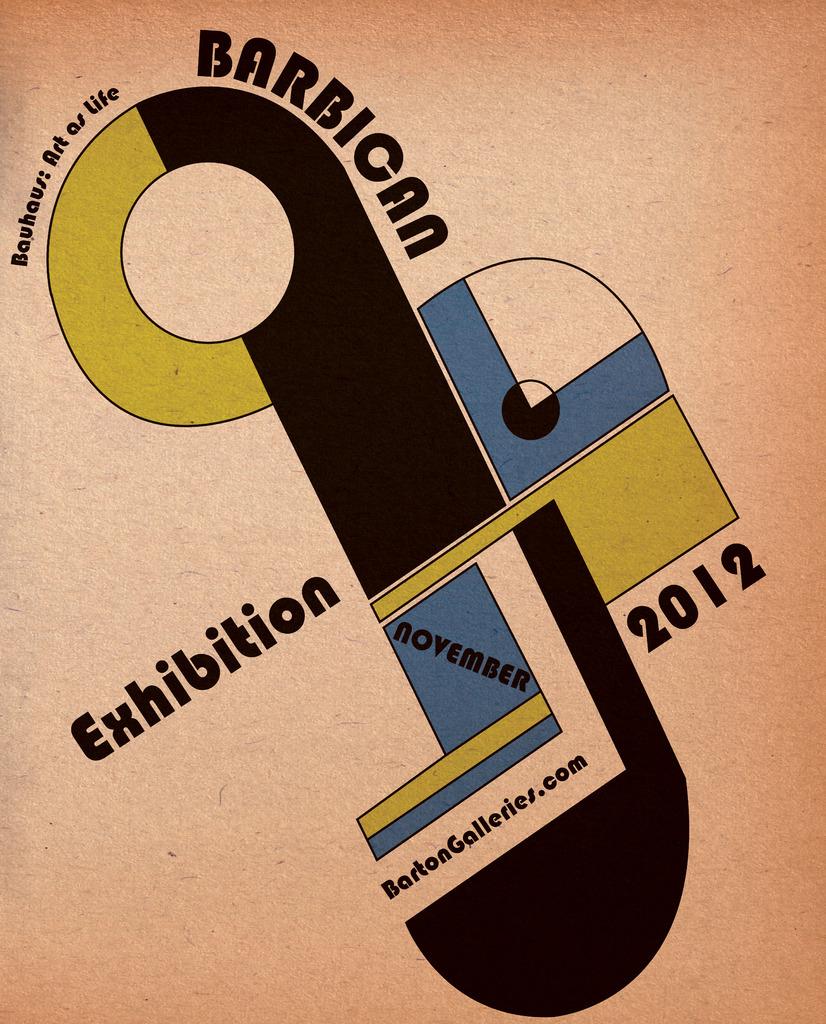What website is shown?
Make the answer very short. Bartongalleries.com. What year is on the ad?
Your answer should be very brief. 2012. 